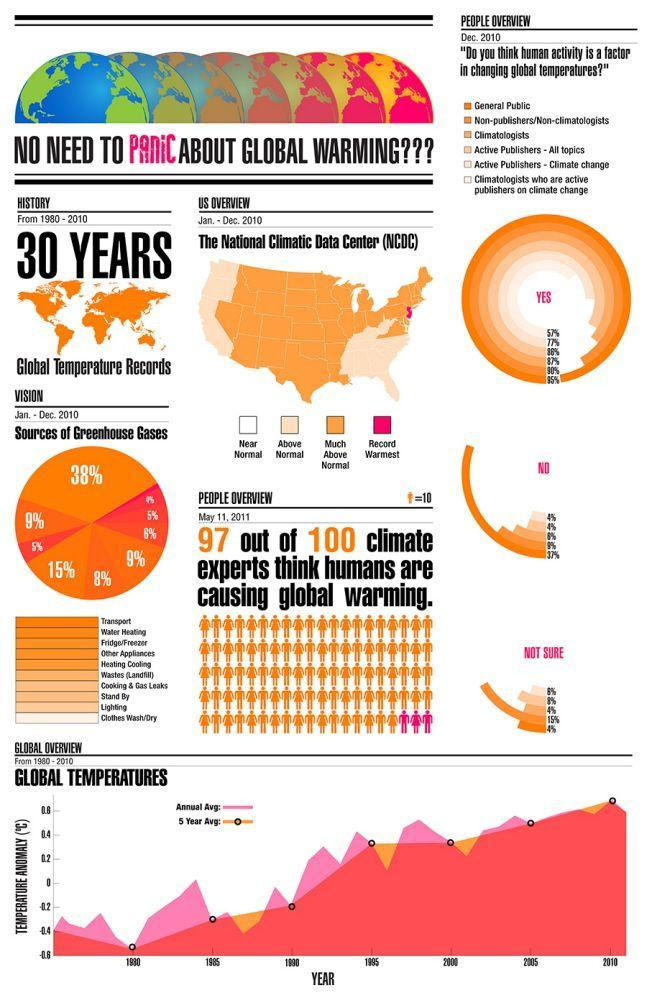What percent of climate experts think that humans are responsible for global warming?
Answer the question with a short phrase. 97% What percent of general public think that human activity is a factor in changing global temperatures? 95% What percent of non-publishers think that human activity does not cause increase in global temperatures? 8% Which is the largest source of greenhouse gases corresponding to 38%? Transport What percent of climatologists are not sure if human activity causes a change in global temperatures? 4% 